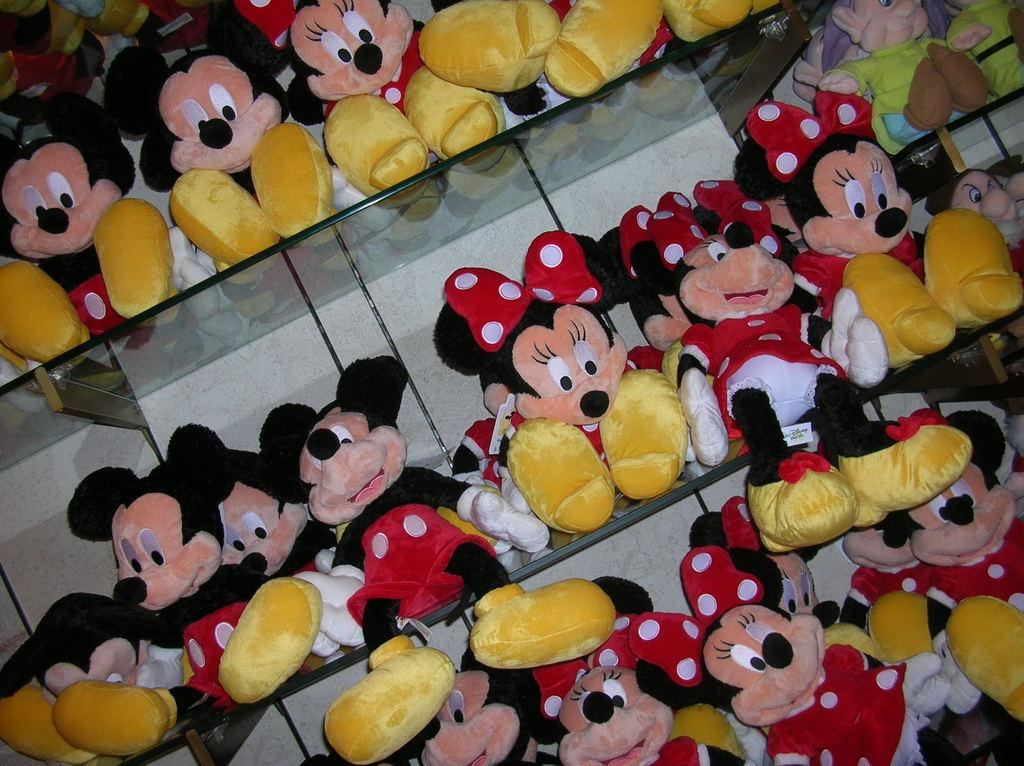What type of furniture is present in the image? There are shelves in the image. What can be seen on the shelves? There are multiple dolls of Mickey Mouse on the shelves. What type of card is being used by the owl in the image? There is no card or owl present in the image; it features shelves with multiple dolls of Mickey Mouse. 